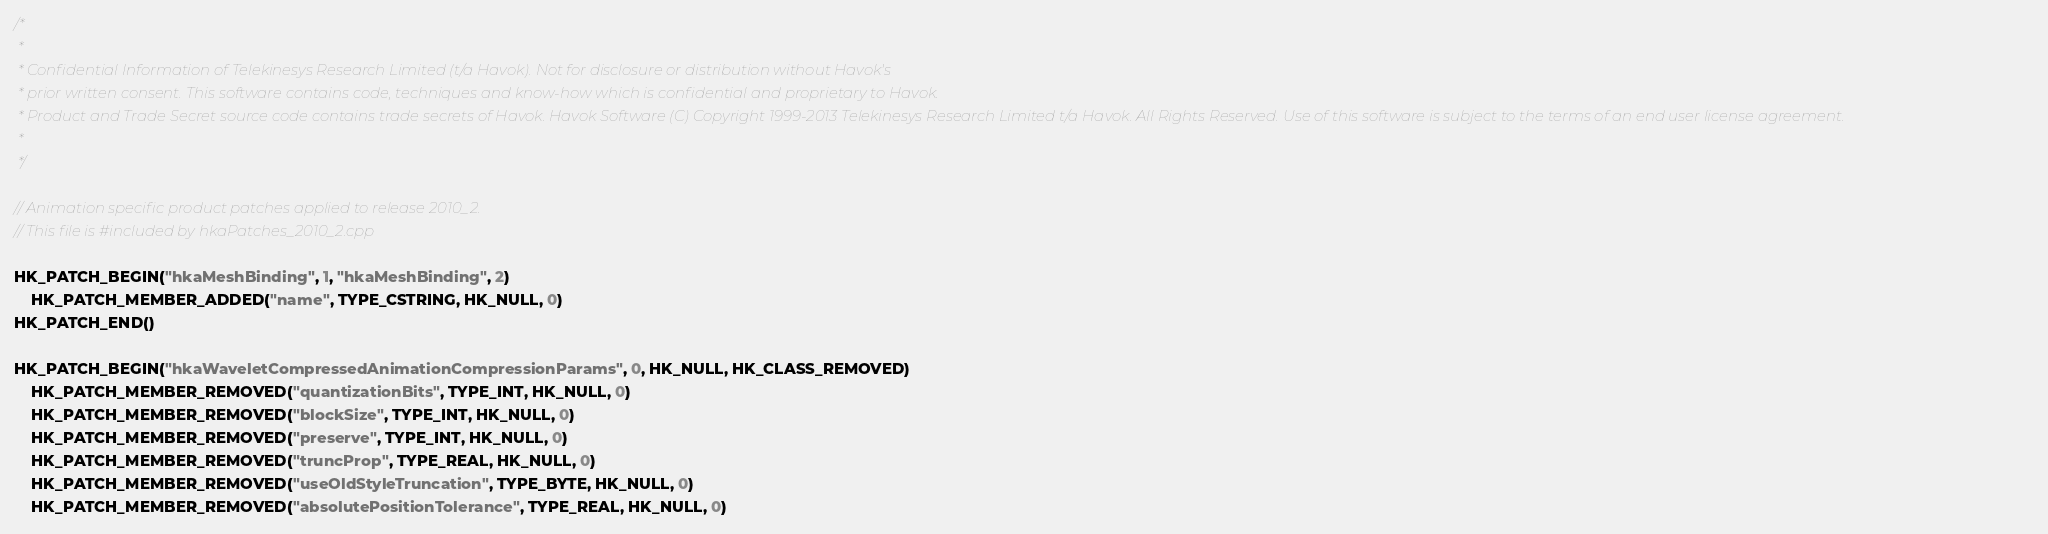<code> <loc_0><loc_0><loc_500><loc_500><_C++_>/*
 *
 * Confidential Information of Telekinesys Research Limited (t/a Havok). Not for disclosure or distribution without Havok's
 * prior written consent. This software contains code, techniques and know-how which is confidential and proprietary to Havok.
 * Product and Trade Secret source code contains trade secrets of Havok. Havok Software (C) Copyright 1999-2013 Telekinesys Research Limited t/a Havok. All Rights Reserved. Use of this software is subject to the terms of an end user license agreement.
 *
 */

// Animation specific product patches applied to release 2010_2.
// This file is #included by hkaPatches_2010_2.cpp

HK_PATCH_BEGIN("hkaMeshBinding", 1, "hkaMeshBinding", 2)
	HK_PATCH_MEMBER_ADDED("name", TYPE_CSTRING, HK_NULL, 0)
HK_PATCH_END()

HK_PATCH_BEGIN("hkaWaveletCompressedAnimationCompressionParams", 0, HK_NULL, HK_CLASS_REMOVED)
	HK_PATCH_MEMBER_REMOVED("quantizationBits", TYPE_INT, HK_NULL, 0)
	HK_PATCH_MEMBER_REMOVED("blockSize", TYPE_INT, HK_NULL, 0)
	HK_PATCH_MEMBER_REMOVED("preserve", TYPE_INT, HK_NULL, 0)
	HK_PATCH_MEMBER_REMOVED("truncProp", TYPE_REAL, HK_NULL, 0)
	HK_PATCH_MEMBER_REMOVED("useOldStyleTruncation", TYPE_BYTE, HK_NULL, 0)
	HK_PATCH_MEMBER_REMOVED("absolutePositionTolerance", TYPE_REAL, HK_NULL, 0)</code> 